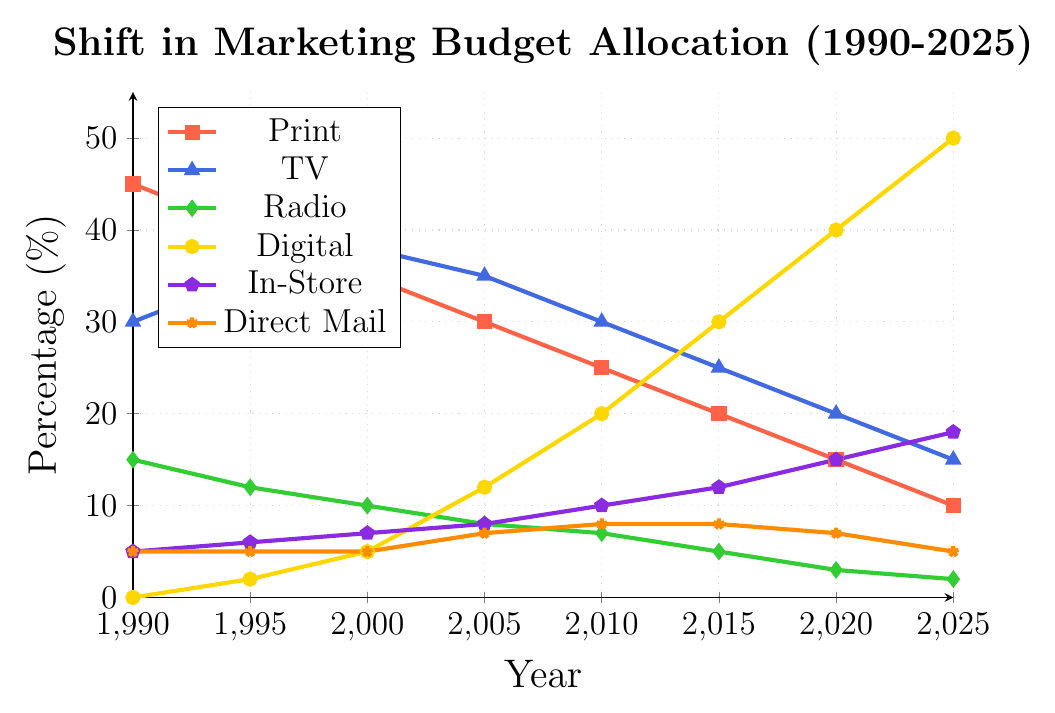What is the percentage difference in the marketing budget allocated to print between 1990 and 2025? In 1990, the marketing budget allocation for print was 45%, and in 2025 it is 10%. The difference is 45% - 10% = 35%.
Answer: 35% Between which years did digital marketing see the largest increase in budget allocation? The digital marketing budget increased progressively over the years. The largest increase happened between 2015 (30%) and 2020 (40%), which is a 10% increase.
Answer: 2015-2020 In 2025, which channel has the second highest budget allocation? In 2025, the digital channel has the highest allocation at 50%. The next highest is the in-store channel at 18%.
Answer: In-Store How did the percentage allocated to TV change from 1990 to 2000? In 1990, the TV budget allocation was 30%. In 2000, it increased to 38%. The change is 38% - 30% = 8%.
Answer: Increased by 8% Which marketing channel saw a consistent decrease in budget allocation from 1990 to 2025? The print channel consistently decreased from 45% in 1990 to 10% in 2025.
Answer: Print Calculate the average percentage allocation for the TV channel between 1990 and 2025. The TV percentages are: 30%, 35%, 38%, 35%, 30%, 25%, 20%, and 15%. Summing these values: 30 + 35 + 38 + 35 + 30 + 25 + 20 + 15 = 228. The average is 228 / 8 = 28.5%.
Answer: 28.5% What is the trend in the allocation of the direct mail budget from 1990 to 2025? The direct mail budget allocation has remained quite stable, starting at 5% in 1990, slightly rising to 7% in 2005 and 2010, and decreasing back to 5% by 2025.
Answer: Stable with minor fluctuations Between 2000 and 2020, which two channels saw increasing budget allocations? Between 2000 and 2020, digital (from 5% to 40%) and in-store (from 7% to 15%) both saw increasing budgets.
Answer: Digital, In-Store From 1990 to 2025, how much did the budget allocation for radio decrease? The radio budget allocation decreased from 15% in 1990 to 2% in 2025. The change is 15% - 2% = 13%.
Answer: 13% Which year did the digital marketing budget first surpass the TV marketing budget? In 2010, the digital budget was 20%, and the TV budget was 30%. By 2015, the digital budget (30%) surpassed the TV budget (25%). The first year this happened was 2015.
Answer: 2015 